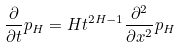Convert formula to latex. <formula><loc_0><loc_0><loc_500><loc_500>\frac { \partial } { \partial t } p _ { H } = H t ^ { 2 H - 1 } \frac { \partial ^ { 2 } } { \partial x ^ { 2 } } p _ { H }</formula> 